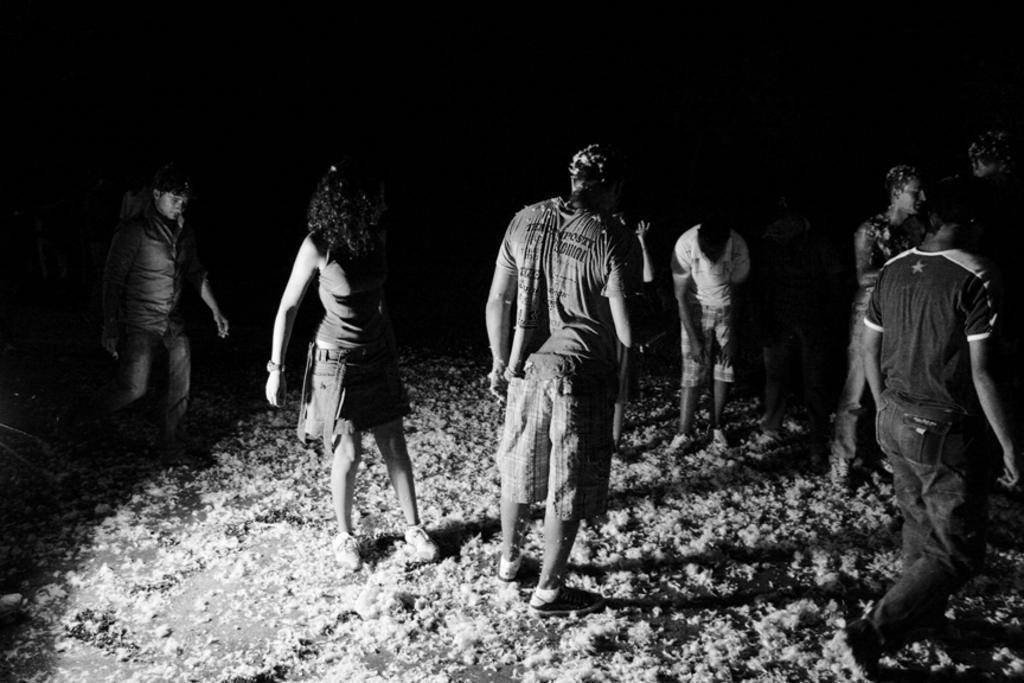Can you describe this image briefly? It is a black and white picture. In the center of the image we can see a few people are standing. And we can see few other objects. 